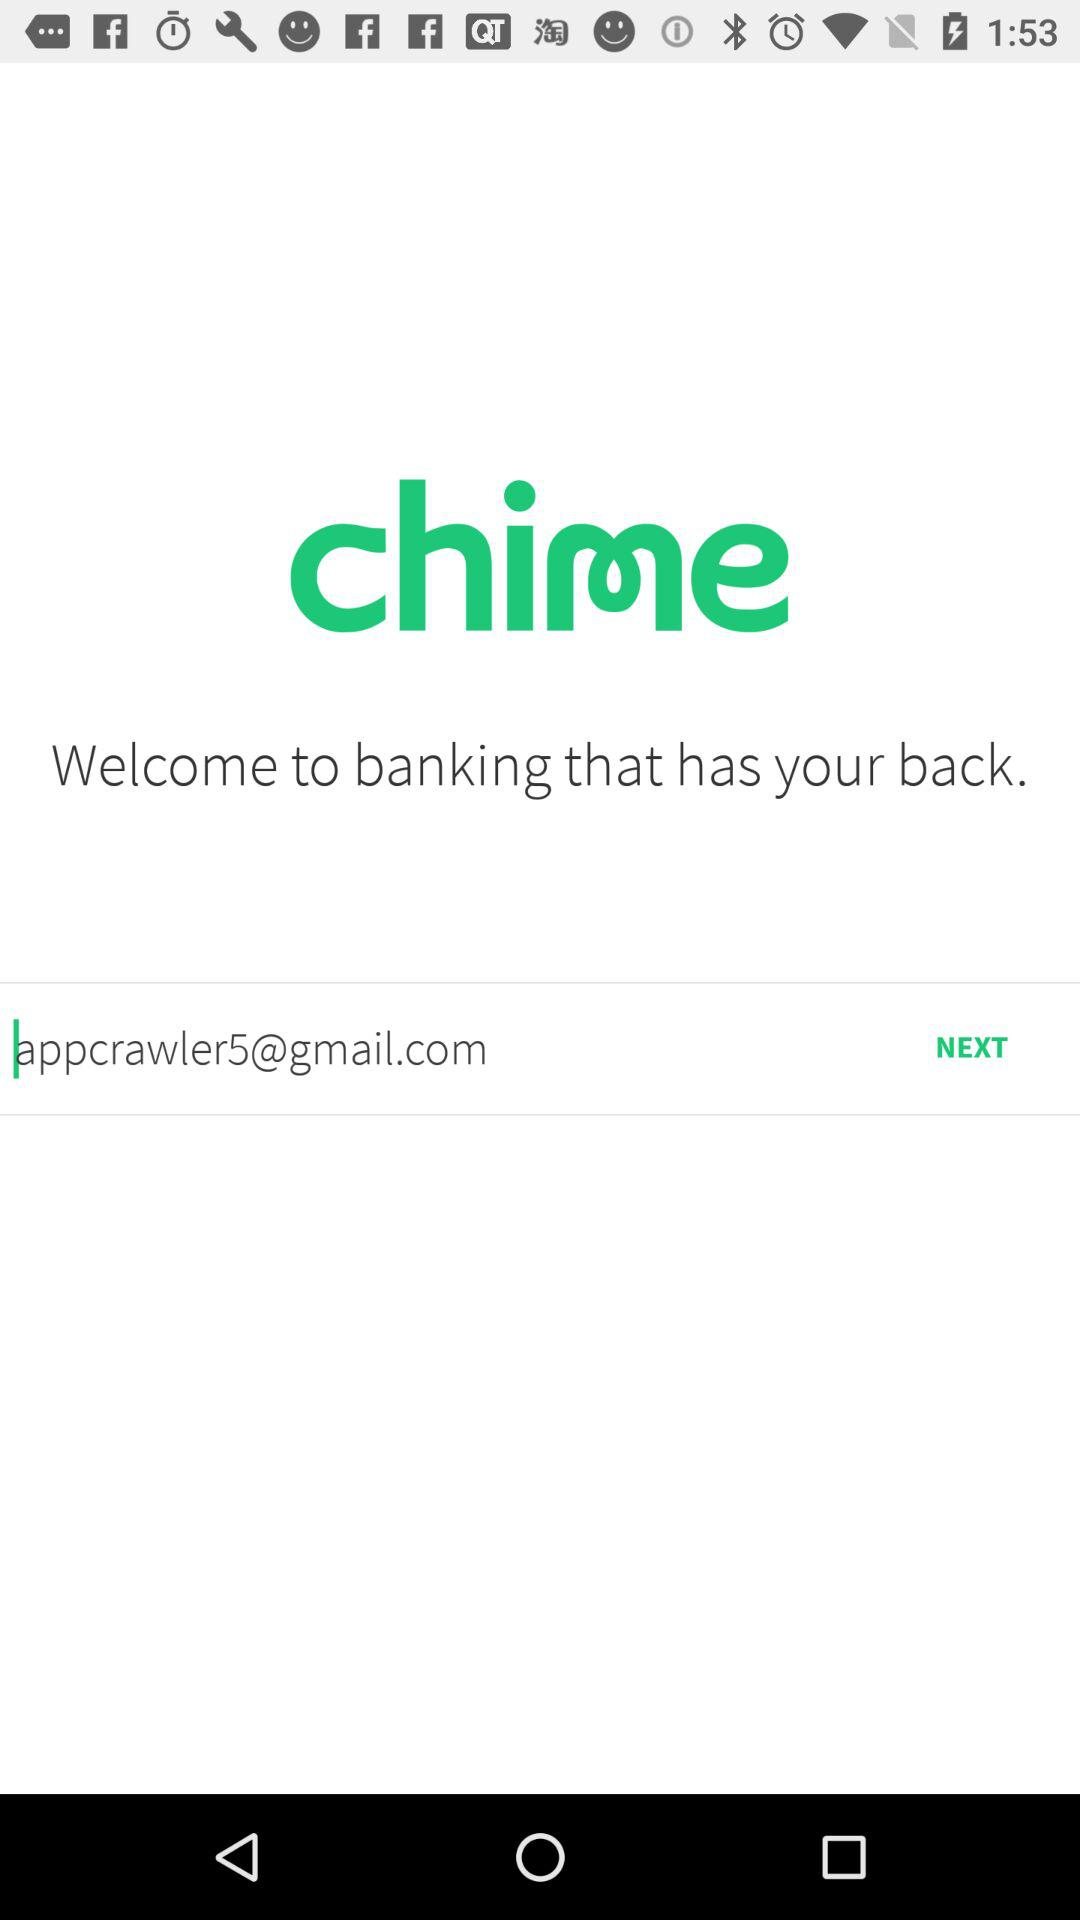What is the given email address? The given email address is appcrawler5@gmail.com. 